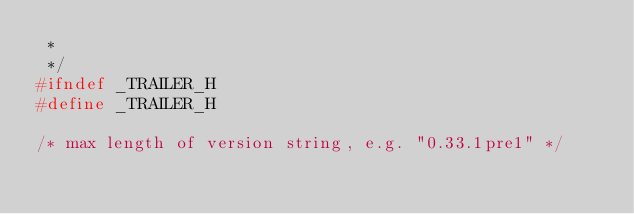<code> <loc_0><loc_0><loc_500><loc_500><_C_> *
 */
#ifndef _TRAILER_H
#define _TRAILER_H

/* max length of version string, e.g. "0.33.1pre1" */</code> 